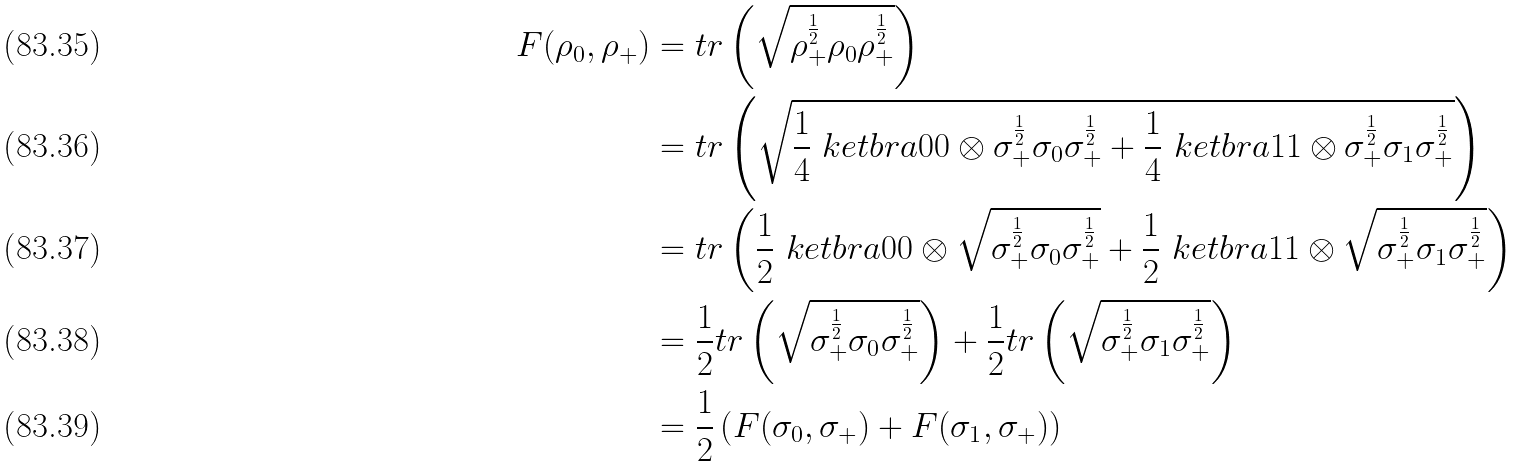Convert formula to latex. <formula><loc_0><loc_0><loc_500><loc_500>F ( \rho _ { 0 } , \rho _ { + } ) & = t r \left ( \sqrt { \rho _ { + } ^ { \frac { 1 } { 2 } } \rho _ { 0 } \rho _ { + } ^ { \frac { 1 } { 2 } } } \right ) \\ & = t r \left ( \sqrt { \frac { 1 } { 4 } \ k e t b r a { 0 } { 0 } \otimes \sigma _ { + } ^ { \frac { 1 } { 2 } } \sigma _ { 0 } \sigma _ { + } ^ { \frac { 1 } { 2 } } + \frac { 1 } { 4 } \ k e t b r a { 1 } { 1 } \otimes \sigma _ { + } ^ { \frac { 1 } { 2 } } \sigma _ { 1 } \sigma _ { + } ^ { \frac { 1 } { 2 } } } \right ) \\ & = t r \left ( \frac { 1 } { 2 } \ k e t b r a { 0 } { 0 } \otimes \sqrt { \sigma _ { + } ^ { \frac { 1 } { 2 } } \sigma _ { 0 } \sigma _ { + } ^ { \frac { 1 } { 2 } } } + \frac { 1 } { 2 } \ k e t b r a { 1 } { 1 } \otimes \sqrt { \sigma _ { + } ^ { \frac { 1 } { 2 } } \sigma _ { 1 } \sigma _ { + } ^ { \frac { 1 } { 2 } } } \right ) \\ & = \frac { 1 } { 2 } t r \left ( \sqrt { \sigma _ { + } ^ { \frac { 1 } { 2 } } \sigma _ { 0 } \sigma _ { + } ^ { \frac { 1 } { 2 } } } \right ) + \frac { 1 } { 2 } t r \left ( \sqrt { \sigma _ { + } ^ { \frac { 1 } { 2 } } \sigma _ { 1 } \sigma _ { + } ^ { \frac { 1 } { 2 } } } \right ) \\ & = \frac { 1 } { 2 } \left ( F ( \sigma _ { 0 } , \sigma _ { + } ) + F ( \sigma _ { 1 } , \sigma _ { + } ) \right )</formula> 